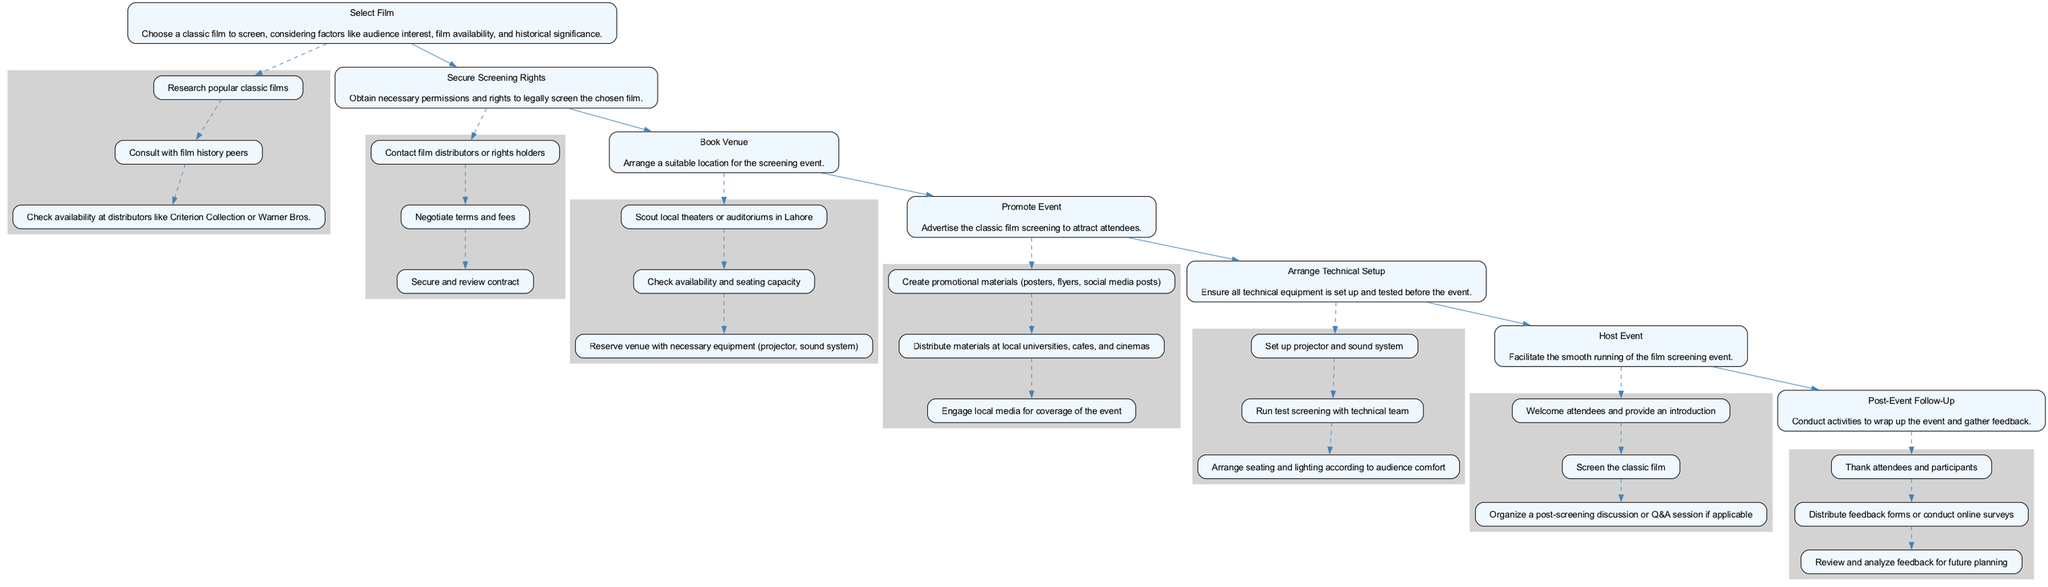What is the first step in organizing a classic film screening event? The diagram shows that the first step is to choose a classic film to screen. This is indicated at the top of the flowchart as "Select Film."
Answer: Select Film How many main steps are there in the flowchart? By counting the main steps outlined in the diagram, there are seven distinct steps from "Select Film" to "Post-Event Follow-Up."
Answer: Seven What is the last sub-step under the "Post-Event Follow-Up" step? The diagram indicates that the last sub-step under "Post-Event Follow-Up" is "Review and analyze feedback for future planning," which wraps up the event process.
Answer: Review and analyze feedback for future planning Which step directly follows "Book Venue"? According to the flowchart, "Promote Event" directly follows "Book Venue" as it is the next step in the sequential process.
Answer: Promote Event What are the sub-steps under "Secure Screening Rights"? The diagram lists three sub-steps under "Secure Screening Rights": "Contact film distributors or rights holders," "Negotiate terms and fees," and "Secure and review contract."
Answer: Contact film distributors or rights holders, Negotiate terms and fees, Secure and review contract Which two steps are connected by a direct edge? The flowchart displays a direct edge between "Arrange Technical Setup" and "Host Event," indicating their sequential relationship in the screening process.
Answer: Arrange Technical Setup and Host Event What type of materials should be created during the "Promote Event" step? The flowchart specifies the creation of promotional materials, such as posters and flyers, as part of the activities undertaken during the "Promote Event" step.
Answer: Promotional materials (posters, flyers) 